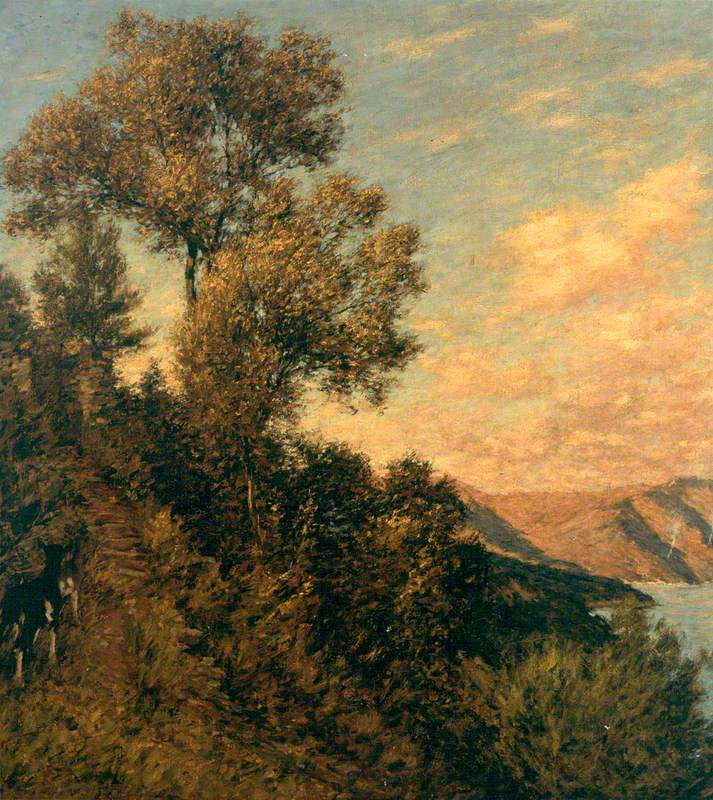What might be the significance of the tree's placement in the painting? The solitary tree's dominant position in the composition serves multiple artistic roles. Symbolically, it could represent resilience or solitude, standing firm on the rocky cliff. From a compositional perspective, its placement on the cliff leading into the scene helps guide the viewer's gaze through the canvas, creating depth and emphasizing the sweeping vista beyond. 